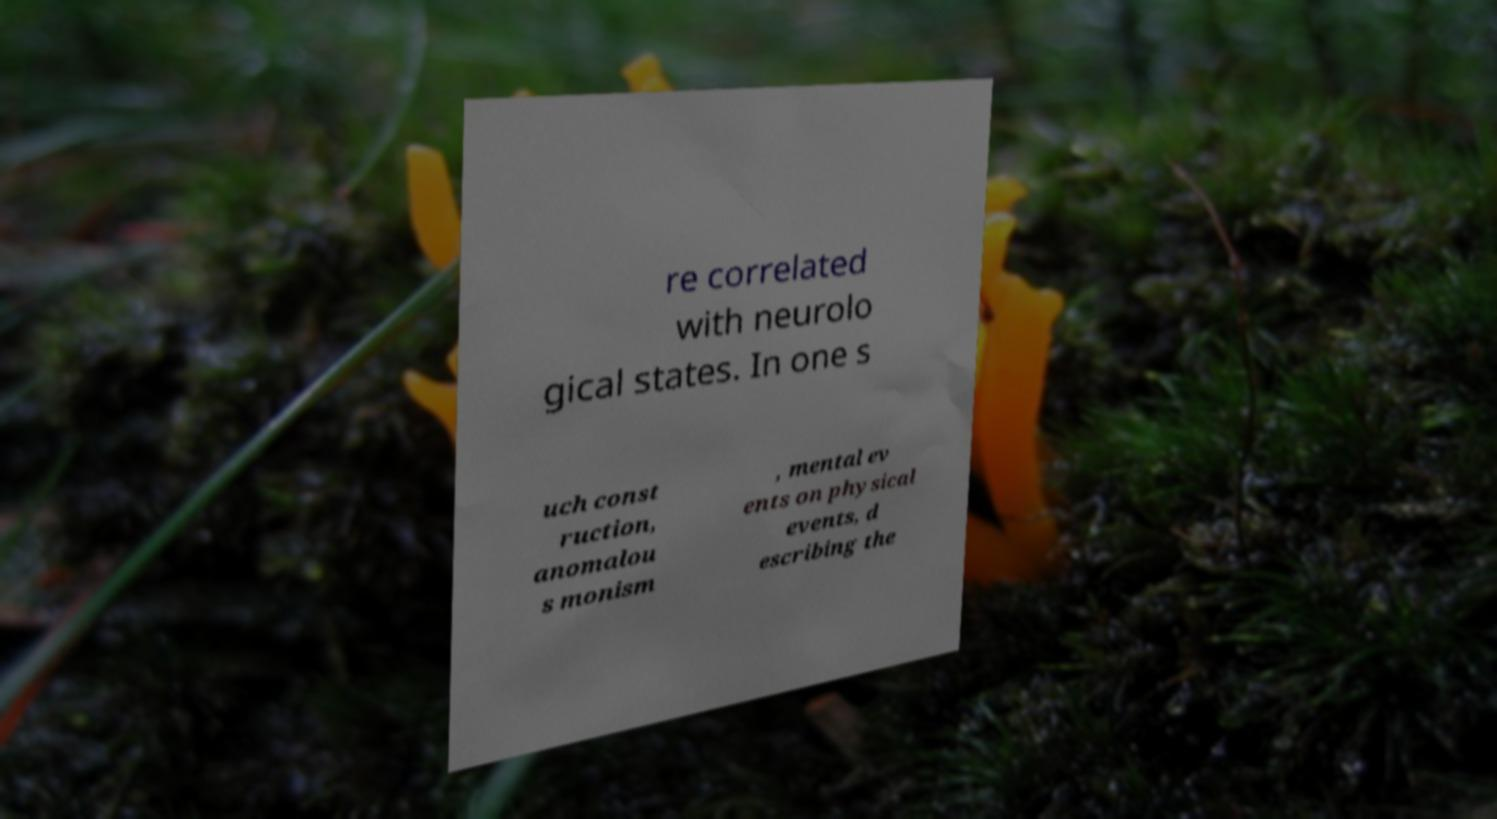For documentation purposes, I need the text within this image transcribed. Could you provide that? re correlated with neurolo gical states. In one s uch const ruction, anomalou s monism , mental ev ents on physical events, d escribing the 